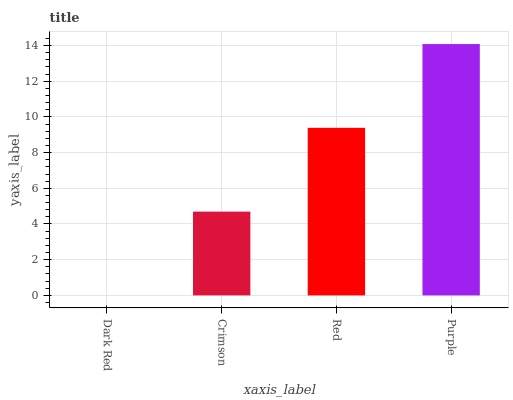Is Crimson the minimum?
Answer yes or no. No. Is Crimson the maximum?
Answer yes or no. No. Is Crimson greater than Dark Red?
Answer yes or no. Yes. Is Dark Red less than Crimson?
Answer yes or no. Yes. Is Dark Red greater than Crimson?
Answer yes or no. No. Is Crimson less than Dark Red?
Answer yes or no. No. Is Red the high median?
Answer yes or no. Yes. Is Crimson the low median?
Answer yes or no. Yes. Is Crimson the high median?
Answer yes or no. No. Is Dark Red the low median?
Answer yes or no. No. 